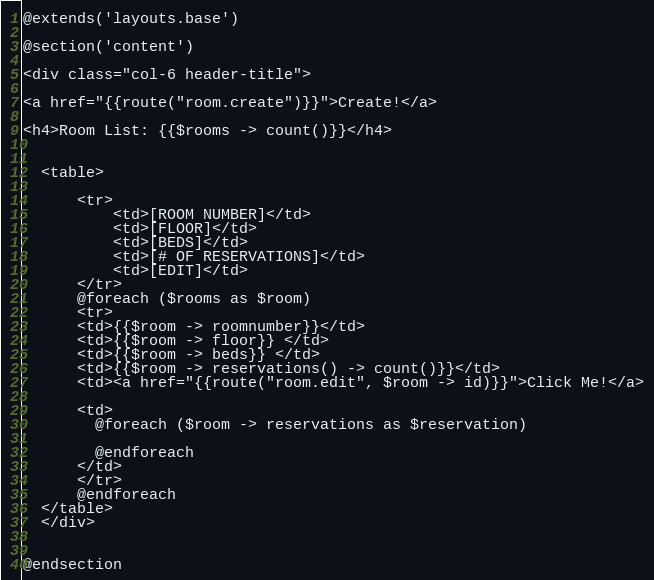<code> <loc_0><loc_0><loc_500><loc_500><_PHP_>@extends('layouts.base')

@section('content')

<div class="col-6 header-title">

<a href="{{route("room.create")}}">Create!</a>

<h4>Room List: {{$rooms -> count()}}</h4>


  <table>

      <tr>
          <td>[ROOM NUMBER]</td>
          <td>[FLOOR]</td>
          <td>[BEDS]</td>
          <td>[# OF RESERVATIONS]</td>
          <td>[EDIT]</td>
      </tr>
      @foreach ($rooms as $room)
      <tr>
      <td>{{$room -> roomnumber}}</td>
      <td>{{$room -> floor}} </td>
      <td>{{$room -> beds}} </td>
      <td>{{$room -> reservations() -> count()}}</td>
      <td><a href="{{route("room.edit", $room -> id)}}">Click Me!</a>

      <td>
        @foreach ($room -> reservations as $reservation)

        @endforeach
      </td>
      </tr>
      @endforeach
  </table>
  </div>


@endsection
</code> 